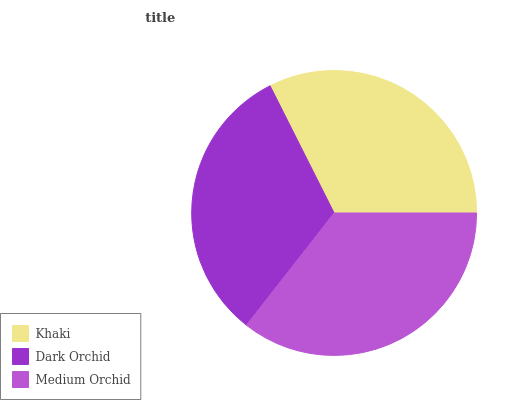Is Dark Orchid the minimum?
Answer yes or no. Yes. Is Medium Orchid the maximum?
Answer yes or no. Yes. Is Medium Orchid the minimum?
Answer yes or no. No. Is Dark Orchid the maximum?
Answer yes or no. No. Is Medium Orchid greater than Dark Orchid?
Answer yes or no. Yes. Is Dark Orchid less than Medium Orchid?
Answer yes or no. Yes. Is Dark Orchid greater than Medium Orchid?
Answer yes or no. No. Is Medium Orchid less than Dark Orchid?
Answer yes or no. No. Is Khaki the high median?
Answer yes or no. Yes. Is Khaki the low median?
Answer yes or no. Yes. Is Dark Orchid the high median?
Answer yes or no. No. Is Medium Orchid the low median?
Answer yes or no. No. 